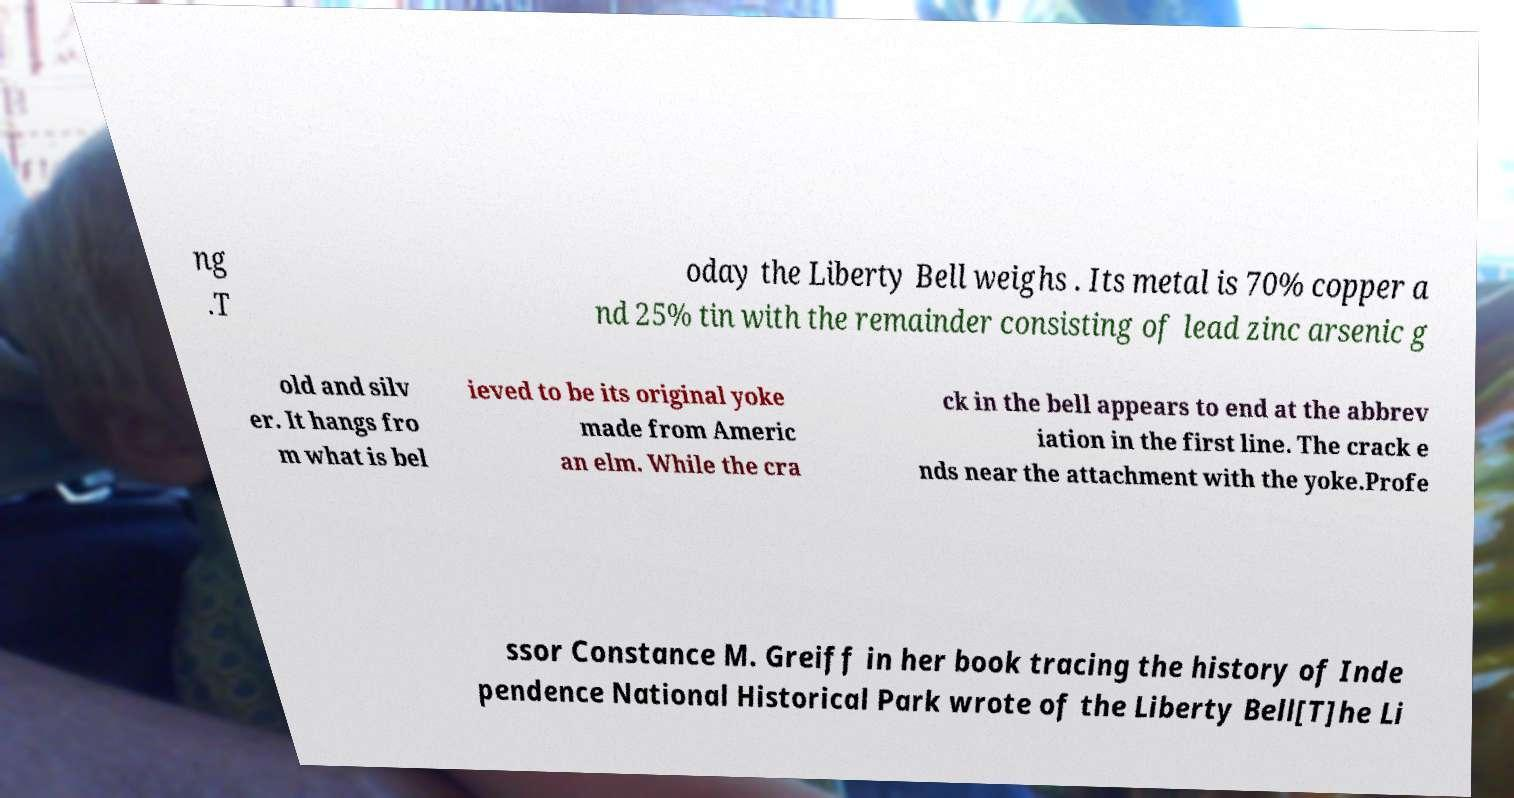Please identify and transcribe the text found in this image. ng .T oday the Liberty Bell weighs . Its metal is 70% copper a nd 25% tin with the remainder consisting of lead zinc arsenic g old and silv er. It hangs fro m what is bel ieved to be its original yoke made from Americ an elm. While the cra ck in the bell appears to end at the abbrev iation in the first line. The crack e nds near the attachment with the yoke.Profe ssor Constance M. Greiff in her book tracing the history of Inde pendence National Historical Park wrote of the Liberty Bell[T]he Li 